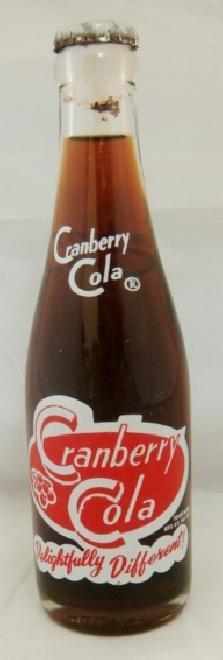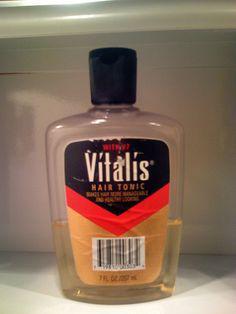The first image is the image on the left, the second image is the image on the right. Considering the images on both sides, is "there is an amber colored empty bottle with no cap on" valid? Answer yes or no. No. The first image is the image on the left, the second image is the image on the right. Considering the images on both sides, is "One bottle is capped and one is not, at least one bottle is brown glass, at least one bottle is empty, and all bottles are beverage bottles." valid? Answer yes or no. No. 